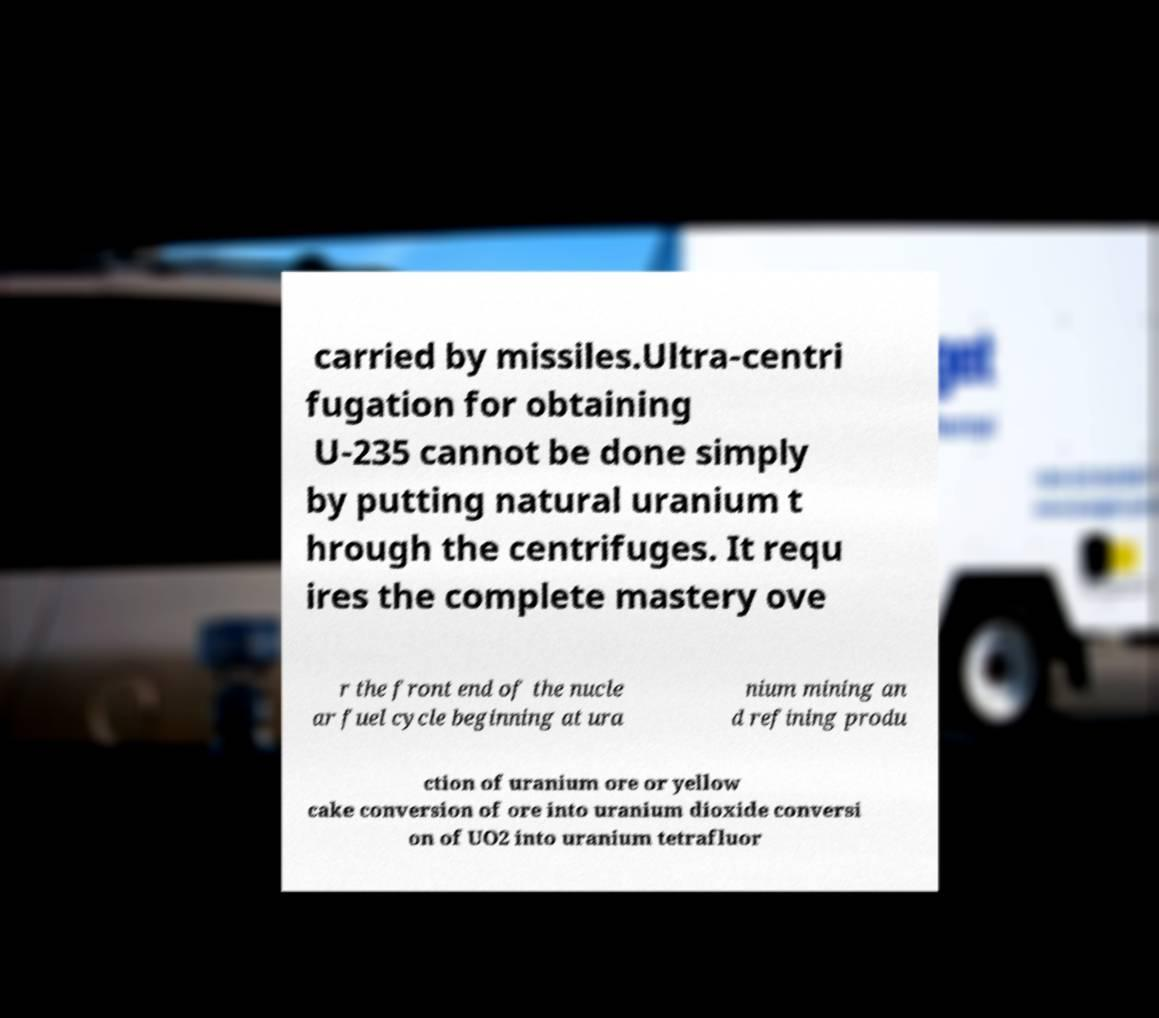What messages or text are displayed in this image? I need them in a readable, typed format. carried by missiles.Ultra-centri fugation for obtaining U-235 cannot be done simply by putting natural uranium t hrough the centrifuges. It requ ires the complete mastery ove r the front end of the nucle ar fuel cycle beginning at ura nium mining an d refining produ ction of uranium ore or yellow cake conversion of ore into uranium dioxide conversi on of UO2 into uranium tetrafluor 